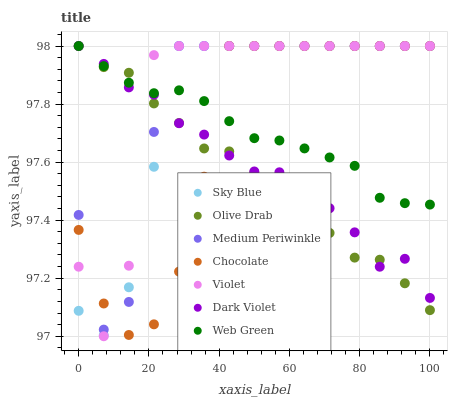Does Olive Drab have the minimum area under the curve?
Answer yes or no. Yes. Does Violet have the maximum area under the curve?
Answer yes or no. Yes. Does Dark Violet have the minimum area under the curve?
Answer yes or no. No. Does Dark Violet have the maximum area under the curve?
Answer yes or no. No. Is Web Green the smoothest?
Answer yes or no. Yes. Is Violet the roughest?
Answer yes or no. Yes. Is Dark Violet the smoothest?
Answer yes or no. No. Is Dark Violet the roughest?
Answer yes or no. No. Does Violet have the lowest value?
Answer yes or no. Yes. Does Dark Violet have the lowest value?
Answer yes or no. No. Does Olive Drab have the highest value?
Answer yes or no. Yes. Does Sky Blue intersect Violet?
Answer yes or no. Yes. Is Sky Blue less than Violet?
Answer yes or no. No. Is Sky Blue greater than Violet?
Answer yes or no. No. 